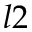Convert formula to latex. <formula><loc_0><loc_0><loc_500><loc_500>l 2</formula> 